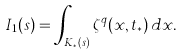<formula> <loc_0><loc_0><loc_500><loc_500>I _ { 1 } ( s ) = \int _ { K _ { * } ( s ) } \zeta ^ { q } ( x , t _ { * } ) \, d x .</formula> 